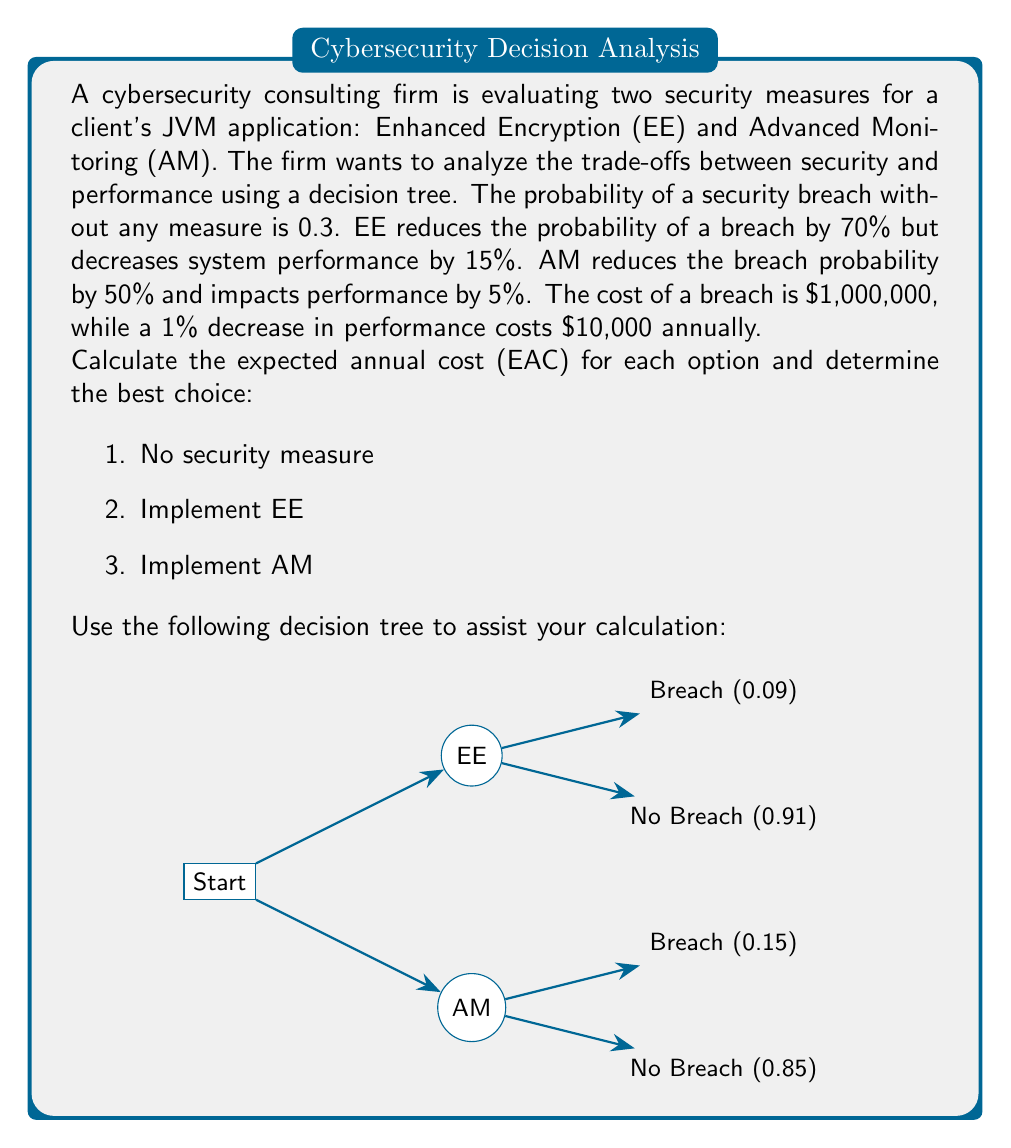Could you help me with this problem? Let's calculate the EAC for each option step-by-step:

1. No security measure:
   - Probability of breach: 0.3
   - EAC = $0.3 \times \$1,000,000 = \$300,000$

2. Implement EE:
   - New probability of breach: $0.3 \times (1 - 0.7) = 0.09$
   - Cost of breach: $0.09 \times \$1,000,000 = \$90,000$
   - Performance cost: $15 \times \$10,000 = \$150,000$
   - EAC = $\$90,000 + \$150,000 = \$240,000$

3. Implement AM:
   - New probability of breach: $0.3 \times (1 - 0.5) = 0.15$
   - Cost of breach: $0.15 \times \$1,000,000 = \$150,000$
   - Performance cost: $5 \times \$10,000 = \$50,000$
   - EAC = $\$150,000 + \$50,000 = \$200,000$

To determine the best choice, we compare the EAC of each option:
- No security measure: $\$300,000$
- Implement EE: $\$240,000$
- Implement AM: $\$200,000$

The option with the lowest EAC is the best choice.
Answer: Implement AM, EAC = $\$200,000$ 